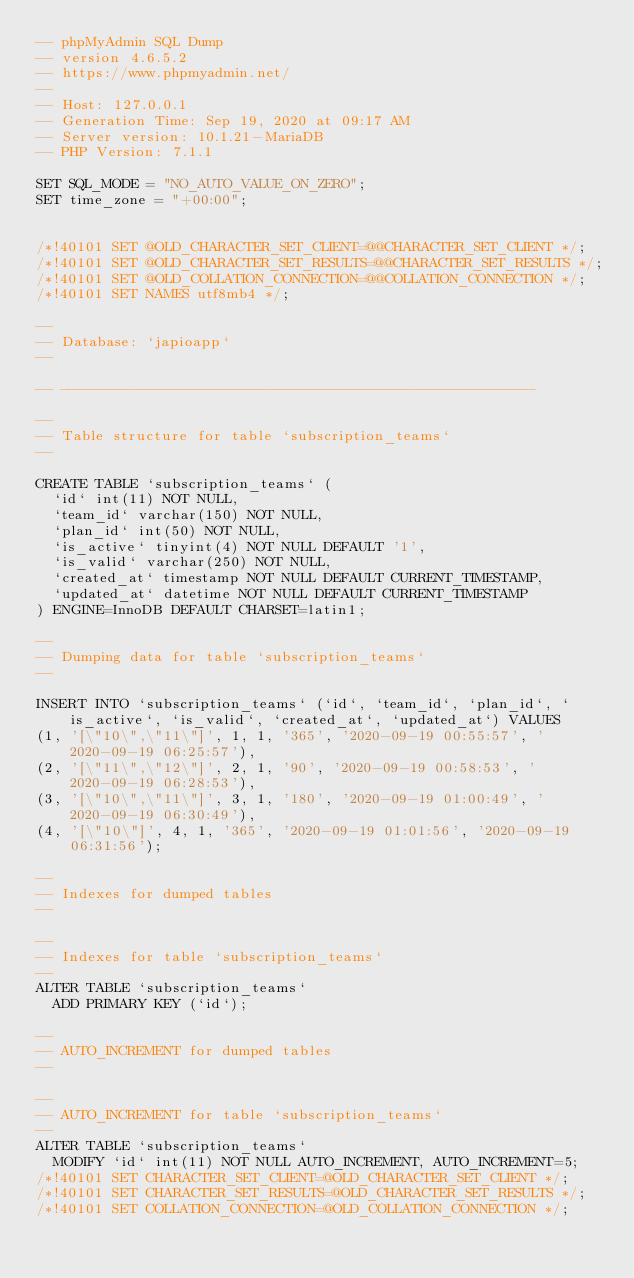Convert code to text. <code><loc_0><loc_0><loc_500><loc_500><_SQL_>-- phpMyAdmin SQL Dump
-- version 4.6.5.2
-- https://www.phpmyadmin.net/
--
-- Host: 127.0.0.1
-- Generation Time: Sep 19, 2020 at 09:17 AM
-- Server version: 10.1.21-MariaDB
-- PHP Version: 7.1.1

SET SQL_MODE = "NO_AUTO_VALUE_ON_ZERO";
SET time_zone = "+00:00";


/*!40101 SET @OLD_CHARACTER_SET_CLIENT=@@CHARACTER_SET_CLIENT */;
/*!40101 SET @OLD_CHARACTER_SET_RESULTS=@@CHARACTER_SET_RESULTS */;
/*!40101 SET @OLD_COLLATION_CONNECTION=@@COLLATION_CONNECTION */;
/*!40101 SET NAMES utf8mb4 */;

--
-- Database: `japioapp`
--

-- --------------------------------------------------------

--
-- Table structure for table `subscription_teams`
--

CREATE TABLE `subscription_teams` (
  `id` int(11) NOT NULL,
  `team_id` varchar(150) NOT NULL,
  `plan_id` int(50) NOT NULL,
  `is_active` tinyint(4) NOT NULL DEFAULT '1',
  `is_valid` varchar(250) NOT NULL,
  `created_at` timestamp NOT NULL DEFAULT CURRENT_TIMESTAMP,
  `updated_at` datetime NOT NULL DEFAULT CURRENT_TIMESTAMP
) ENGINE=InnoDB DEFAULT CHARSET=latin1;

--
-- Dumping data for table `subscription_teams`
--

INSERT INTO `subscription_teams` (`id`, `team_id`, `plan_id`, `is_active`, `is_valid`, `created_at`, `updated_at`) VALUES
(1, '[\"10\",\"11\"]', 1, 1, '365', '2020-09-19 00:55:57', '2020-09-19 06:25:57'),
(2, '[\"11\",\"12\"]', 2, 1, '90', '2020-09-19 00:58:53', '2020-09-19 06:28:53'),
(3, '[\"10\",\"11\"]', 3, 1, '180', '2020-09-19 01:00:49', '2020-09-19 06:30:49'),
(4, '[\"10\"]', 4, 1, '365', '2020-09-19 01:01:56', '2020-09-19 06:31:56');

--
-- Indexes for dumped tables
--

--
-- Indexes for table `subscription_teams`
--
ALTER TABLE `subscription_teams`
  ADD PRIMARY KEY (`id`);

--
-- AUTO_INCREMENT for dumped tables
--

--
-- AUTO_INCREMENT for table `subscription_teams`
--
ALTER TABLE `subscription_teams`
  MODIFY `id` int(11) NOT NULL AUTO_INCREMENT, AUTO_INCREMENT=5;
/*!40101 SET CHARACTER_SET_CLIENT=@OLD_CHARACTER_SET_CLIENT */;
/*!40101 SET CHARACTER_SET_RESULTS=@OLD_CHARACTER_SET_RESULTS */;
/*!40101 SET COLLATION_CONNECTION=@OLD_COLLATION_CONNECTION */;
</code> 